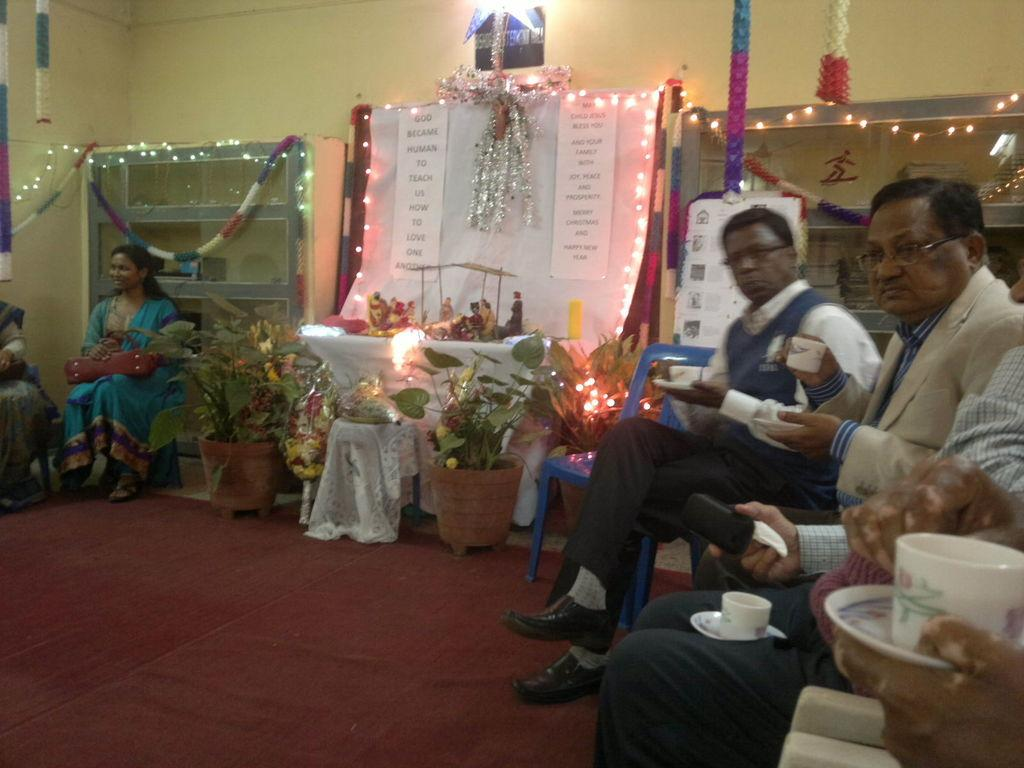What are the people in the image doing? The persons sitting on chairs in the foreground of the image are likely resting or engaged in conversation. What can be seen on the ground in the foreground of the image? There are plants on the ground in the foreground of the image. What is hanging from the ceiling in the foreground of the image? There are decoration items on the ceiling in the foreground of the image. What type of furniture is present in the foreground of the image? There are cupboards in the foreground of the image. What is the background of the image made of? There is a wall visible in the foreground of the image, which suggests the background is made of a solid material like brick or concrete. What type of mint can be seen growing on the wall in the image? There is no mint visible in the image; the wall is not described as having any vegetation. What type of steel appliance is present on the ground in the image? There is no steel appliance present in the image; the objects on the ground are plants. 